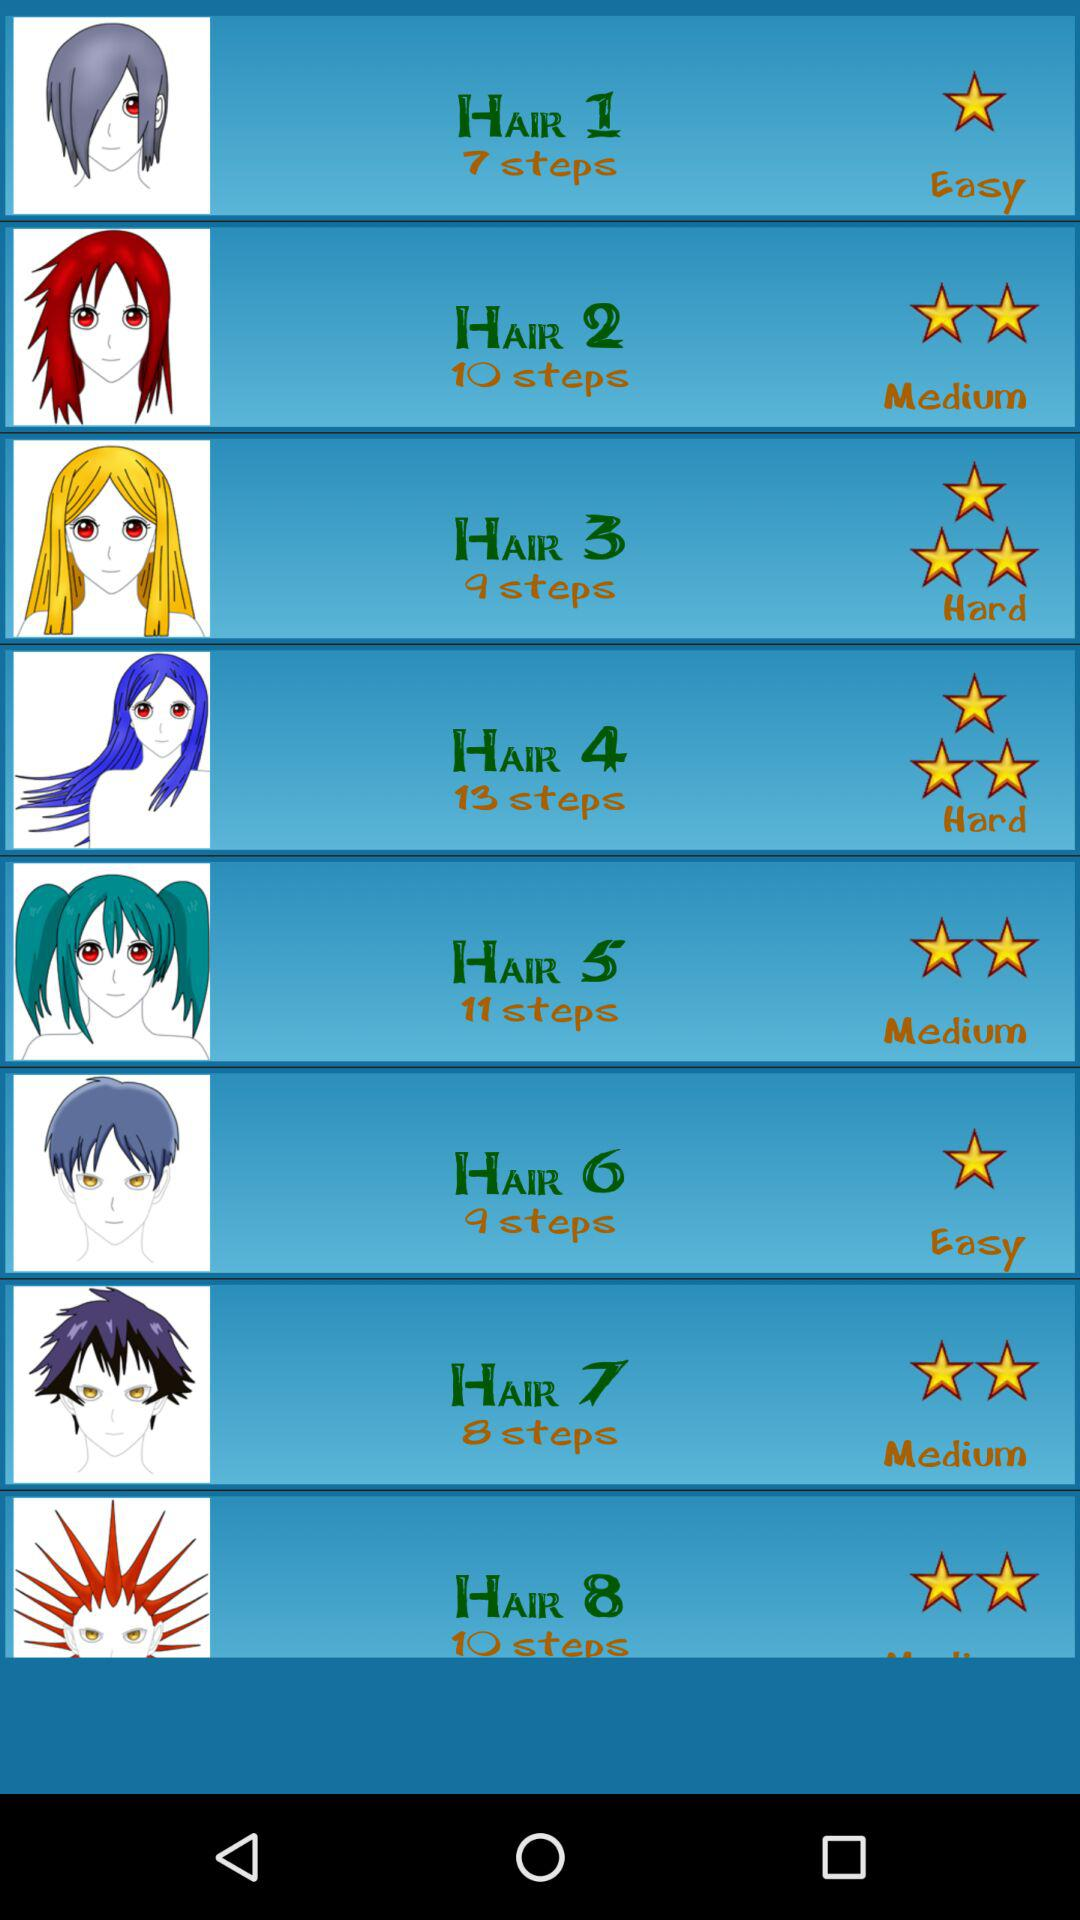Which hairstyle has one star as a difficulty level? The hairstyles that have one star as a difficulty level are "HAIR 1" and "HAIR 6". 